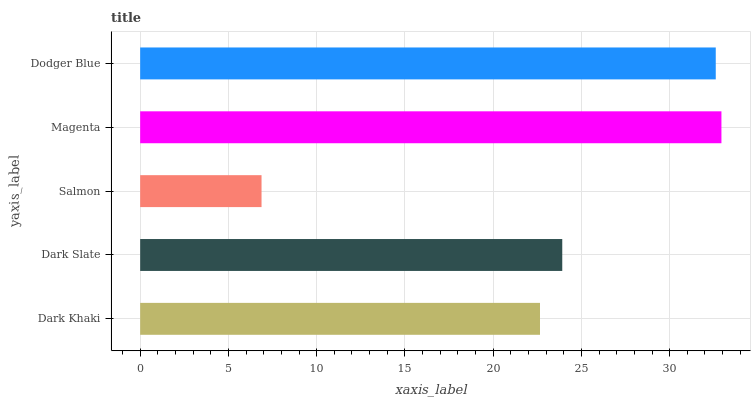Is Salmon the minimum?
Answer yes or no. Yes. Is Magenta the maximum?
Answer yes or no. Yes. Is Dark Slate the minimum?
Answer yes or no. No. Is Dark Slate the maximum?
Answer yes or no. No. Is Dark Slate greater than Dark Khaki?
Answer yes or no. Yes. Is Dark Khaki less than Dark Slate?
Answer yes or no. Yes. Is Dark Khaki greater than Dark Slate?
Answer yes or no. No. Is Dark Slate less than Dark Khaki?
Answer yes or no. No. Is Dark Slate the high median?
Answer yes or no. Yes. Is Dark Slate the low median?
Answer yes or no. Yes. Is Dodger Blue the high median?
Answer yes or no. No. Is Salmon the low median?
Answer yes or no. No. 